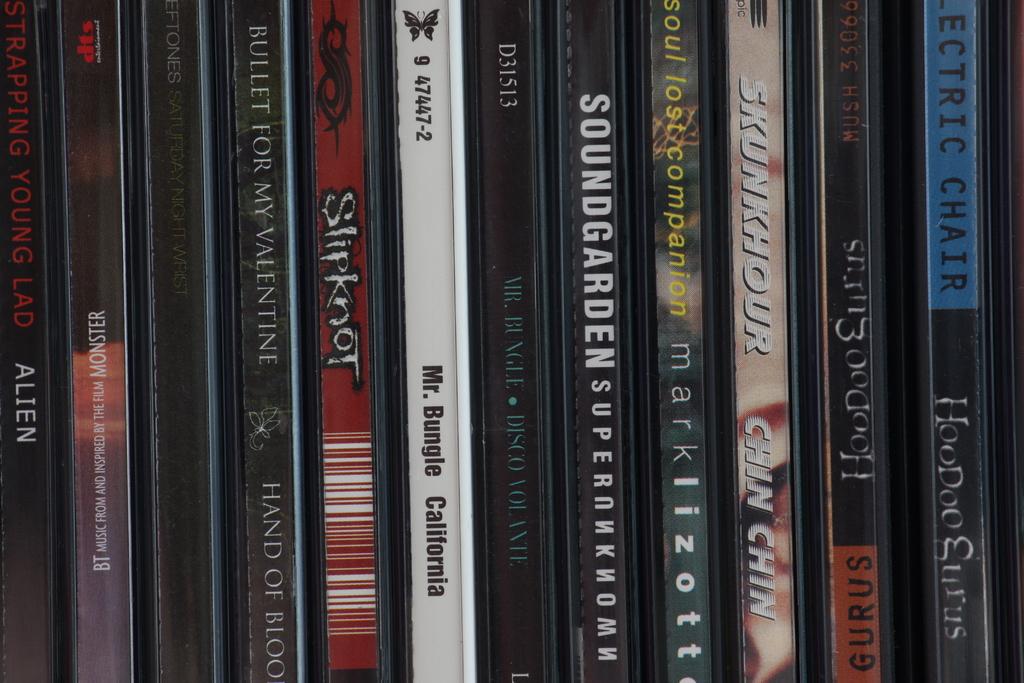Name a band from one these cds?
Provide a short and direct response. Slipknot. 